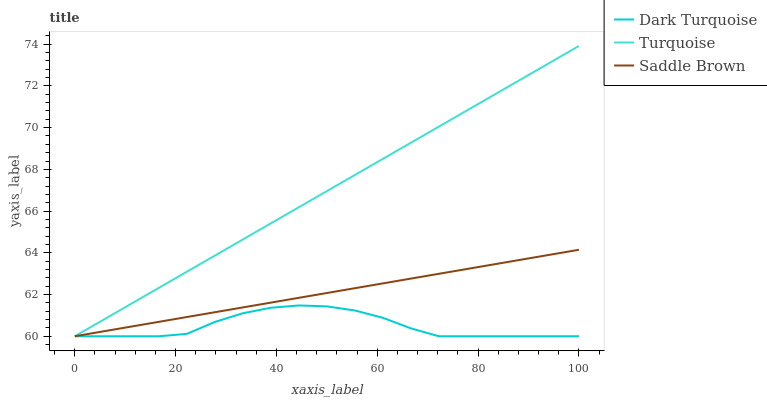Does Dark Turquoise have the minimum area under the curve?
Answer yes or no. Yes. Does Turquoise have the maximum area under the curve?
Answer yes or no. Yes. Does Saddle Brown have the minimum area under the curve?
Answer yes or no. No. Does Saddle Brown have the maximum area under the curve?
Answer yes or no. No. Is Turquoise the smoothest?
Answer yes or no. Yes. Is Dark Turquoise the roughest?
Answer yes or no. Yes. Is Saddle Brown the smoothest?
Answer yes or no. No. Is Saddle Brown the roughest?
Answer yes or no. No. Does Dark Turquoise have the lowest value?
Answer yes or no. Yes. Does Turquoise have the highest value?
Answer yes or no. Yes. Does Saddle Brown have the highest value?
Answer yes or no. No. Does Dark Turquoise intersect Turquoise?
Answer yes or no. Yes. Is Dark Turquoise less than Turquoise?
Answer yes or no. No. Is Dark Turquoise greater than Turquoise?
Answer yes or no. No. 